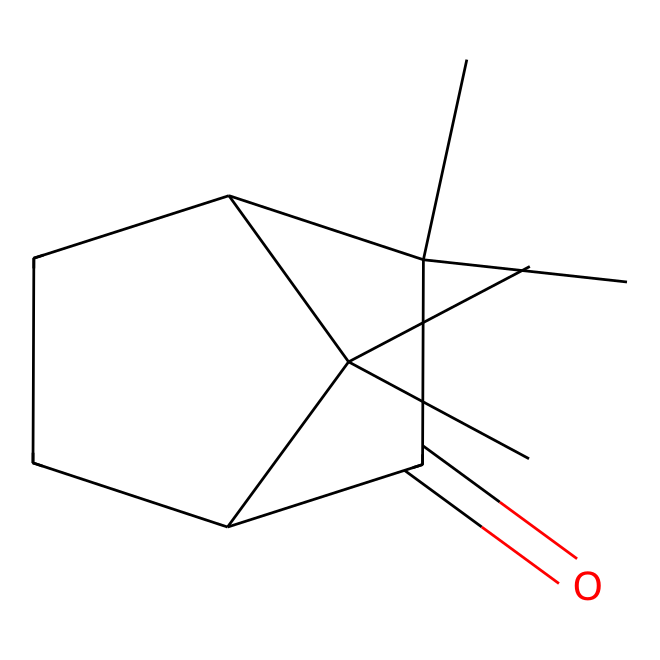What is the name of the compound represented by this SMILES? The SMILES representation corresponds to the structure of camphor, a bicyclic monoterpene.
Answer: camphor How many carbon atoms are in this compound? By analyzing the SMILES, we can count a total of 10 carbon atoms (C).
Answer: 10 How many oxygen atoms does camphor contain? The SMILES shows one oxygen atom (O) in the carbonyl group (C=O).
Answer: 1 Is camphor a cyclic compound? The structure includes rings (bicyclic) based on the presence of enclosed carbon pathways, indicating a cyclic nature.
Answer: Yes What type of functional group is present in camphor? The compound contains a carbonyl group (C=O) which is characteristic of ketones.
Answer: ketone What physical state is camphor typically found in at room temperature? Camphor is known to be a solid at room temperature, which is typical for many organic compounds with this structure.
Answer: solid What aromatic quality does camphor possess? Camphor has a characteristic strong aromatic scent due to its structure, which is commonly used in fragrances.
Answer: aromatic 